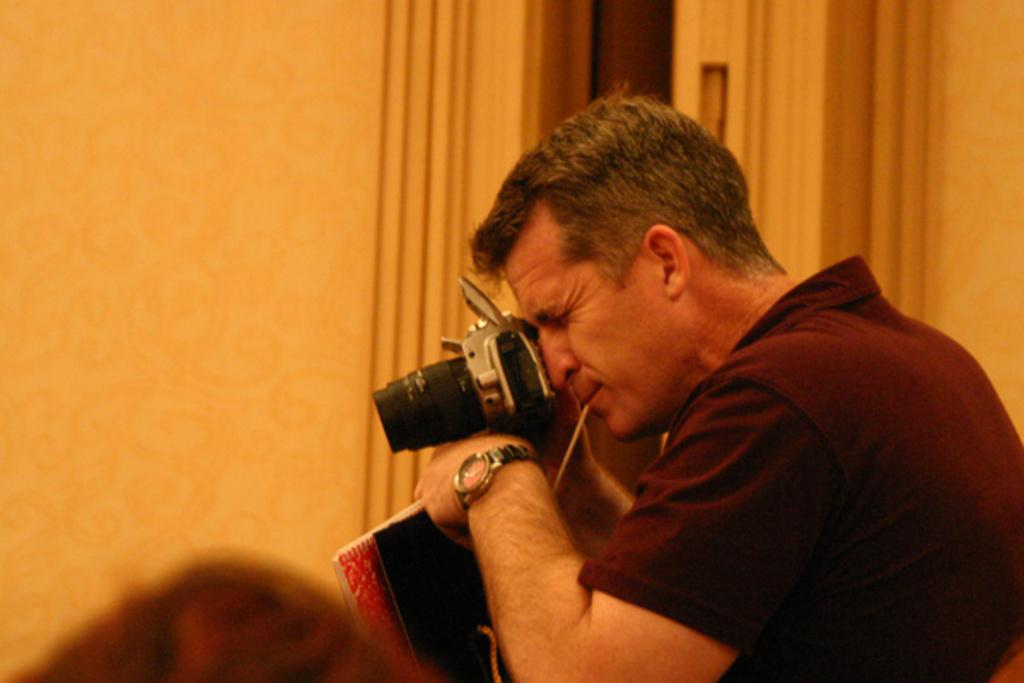What is the main subject of the image? There is a person in the image. What is the person holding in the image? The person is holding a camera. What can be seen in the background of the image? There is a wall in the background of the image. What type of van can be seen in the advertisement in the image? There is no van or advertisement present in the image; it only features a person holding a camera with a wall in the background. 